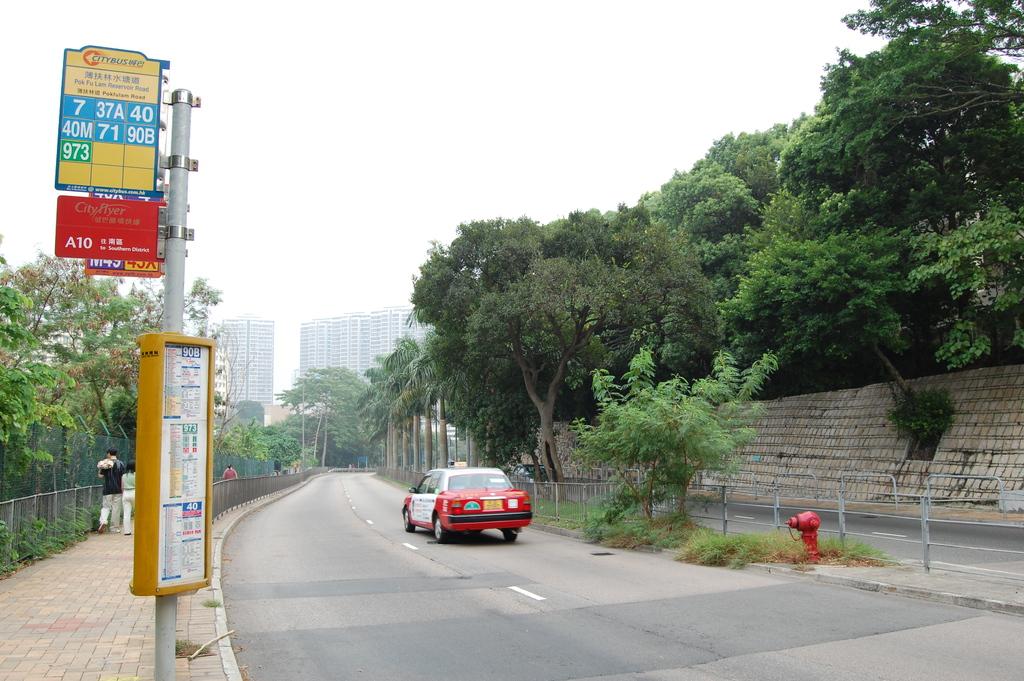What are the numbers with the green background?
Provide a succinct answer. 973. 